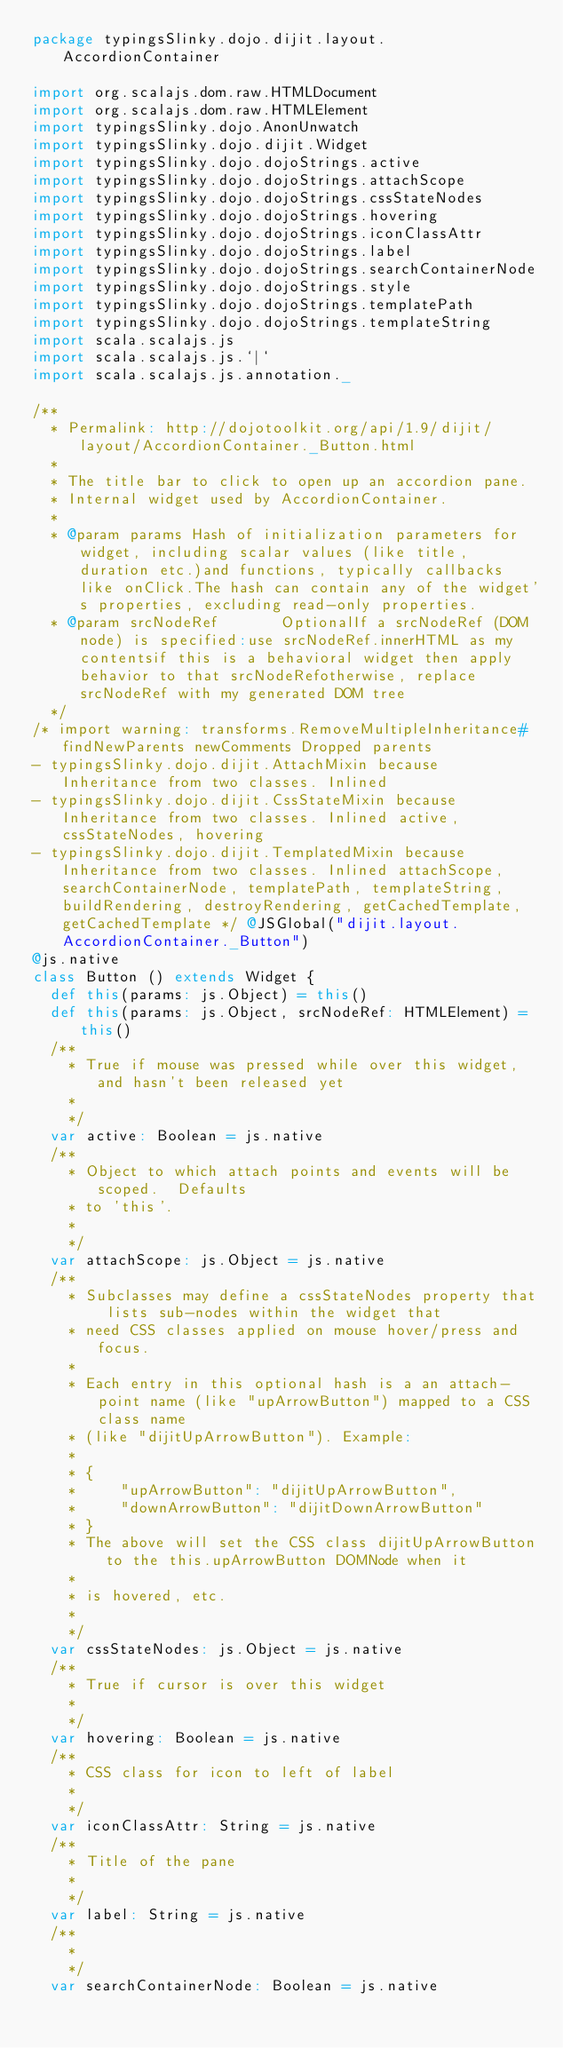<code> <loc_0><loc_0><loc_500><loc_500><_Scala_>package typingsSlinky.dojo.dijit.layout.AccordionContainer

import org.scalajs.dom.raw.HTMLDocument
import org.scalajs.dom.raw.HTMLElement
import typingsSlinky.dojo.AnonUnwatch
import typingsSlinky.dojo.dijit.Widget
import typingsSlinky.dojo.dojoStrings.active
import typingsSlinky.dojo.dojoStrings.attachScope
import typingsSlinky.dojo.dojoStrings.cssStateNodes
import typingsSlinky.dojo.dojoStrings.hovering
import typingsSlinky.dojo.dojoStrings.iconClassAttr
import typingsSlinky.dojo.dojoStrings.label
import typingsSlinky.dojo.dojoStrings.searchContainerNode
import typingsSlinky.dojo.dojoStrings.style
import typingsSlinky.dojo.dojoStrings.templatePath
import typingsSlinky.dojo.dojoStrings.templateString
import scala.scalajs.js
import scala.scalajs.js.`|`
import scala.scalajs.js.annotation._

/**
  * Permalink: http://dojotoolkit.org/api/1.9/dijit/layout/AccordionContainer._Button.html
  *
  * The title bar to click to open up an accordion pane.
  * Internal widget used by AccordionContainer.
  * 
  * @param params Hash of initialization parameters for widget, including scalar values (like title, duration etc.)and functions, typically callbacks like onClick.The hash can contain any of the widget's properties, excluding read-only properties.     
  * @param srcNodeRef       OptionalIf a srcNodeRef (DOM node) is specified:use srcNodeRef.innerHTML as my contentsif this is a behavioral widget then apply behavior to that srcNodeRefotherwise, replace srcNodeRef with my generated DOM tree     
  */
/* import warning: transforms.RemoveMultipleInheritance#findNewParents newComments Dropped parents 
- typingsSlinky.dojo.dijit.AttachMixin because Inheritance from two classes. Inlined 
- typingsSlinky.dojo.dijit.CssStateMixin because Inheritance from two classes. Inlined active, cssStateNodes, hovering
- typingsSlinky.dojo.dijit.TemplatedMixin because Inheritance from two classes. Inlined attachScope, searchContainerNode, templatePath, templateString, buildRendering, destroyRendering, getCachedTemplate, getCachedTemplate */ @JSGlobal("dijit.layout.AccordionContainer._Button")
@js.native
class Button () extends Widget {
  def this(params: js.Object) = this()
  def this(params: js.Object, srcNodeRef: HTMLElement) = this()
  /**
    * True if mouse was pressed while over this widget, and hasn't been released yet
    * 
    */
  var active: Boolean = js.native
  /**
    * Object to which attach points and events will be scoped.  Defaults
    * to 'this'.
    * 
    */
  var attachScope: js.Object = js.native
  /**
    * Subclasses may define a cssStateNodes property that lists sub-nodes within the widget that
    * need CSS classes applied on mouse hover/press and focus.
    * 
    * Each entry in this optional hash is a an attach-point name (like "upArrowButton") mapped to a CSS class name
    * (like "dijitUpArrowButton"). Example:
    * 
    * {
    *     "upArrowButton": "dijitUpArrowButton",
    *     "downArrowButton": "dijitDownArrowButton"
    * }
    * The above will set the CSS class dijitUpArrowButton to the this.upArrowButton DOMNode when it
    * 
    * is hovered, etc.
    * 
    */
  var cssStateNodes: js.Object = js.native
  /**
    * True if cursor is over this widget
    * 
    */
  var hovering: Boolean = js.native
  /**
    * CSS class for icon to left of label
    * 
    */
  var iconClassAttr: String = js.native
  /**
    * Title of the pane
    * 
    */
  var label: String = js.native
  /**
    * 
    */
  var searchContainerNode: Boolean = js.native</code> 